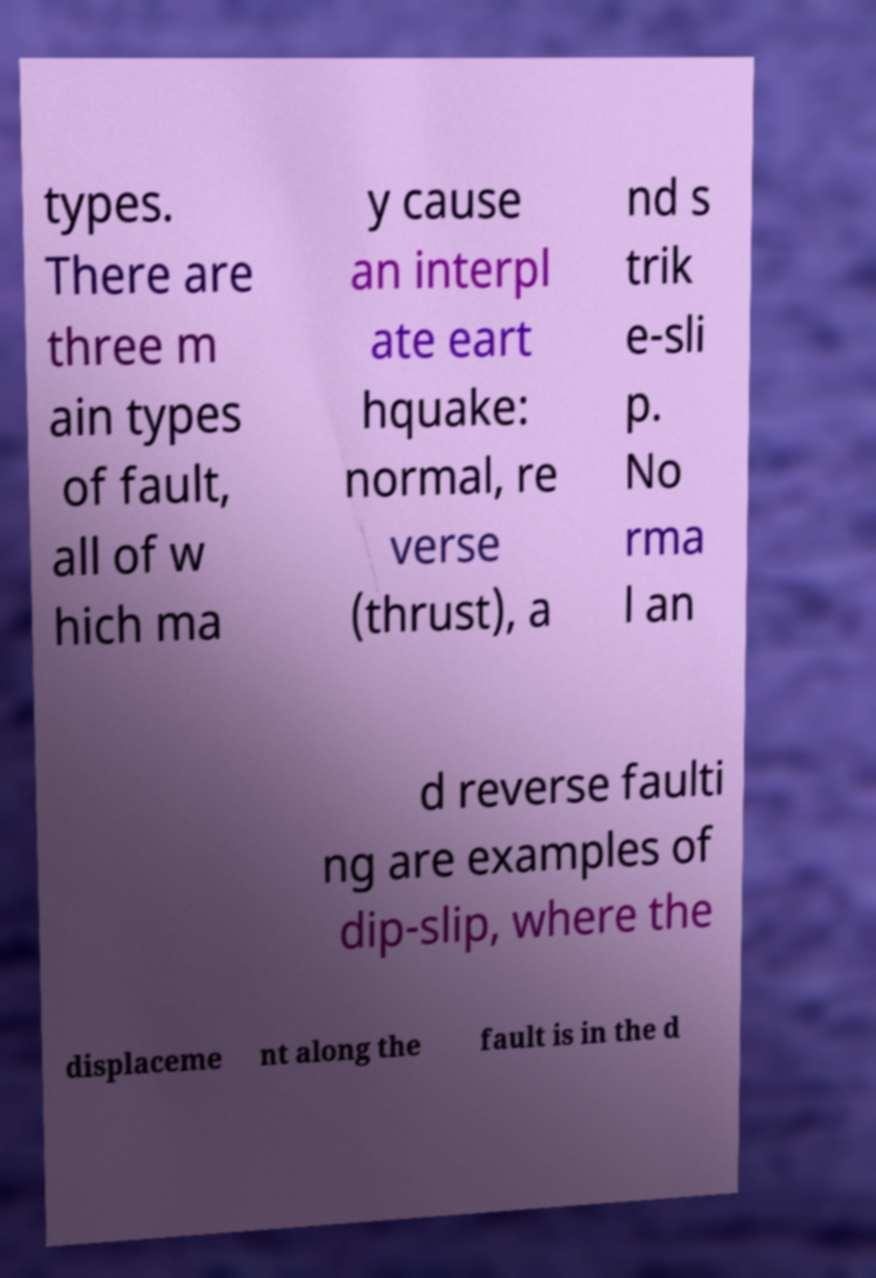Could you extract and type out the text from this image? types. There are three m ain types of fault, all of w hich ma y cause an interpl ate eart hquake: normal, re verse (thrust), a nd s trik e-sli p. No rma l an d reverse faulti ng are examples of dip-slip, where the displaceme nt along the fault is in the d 